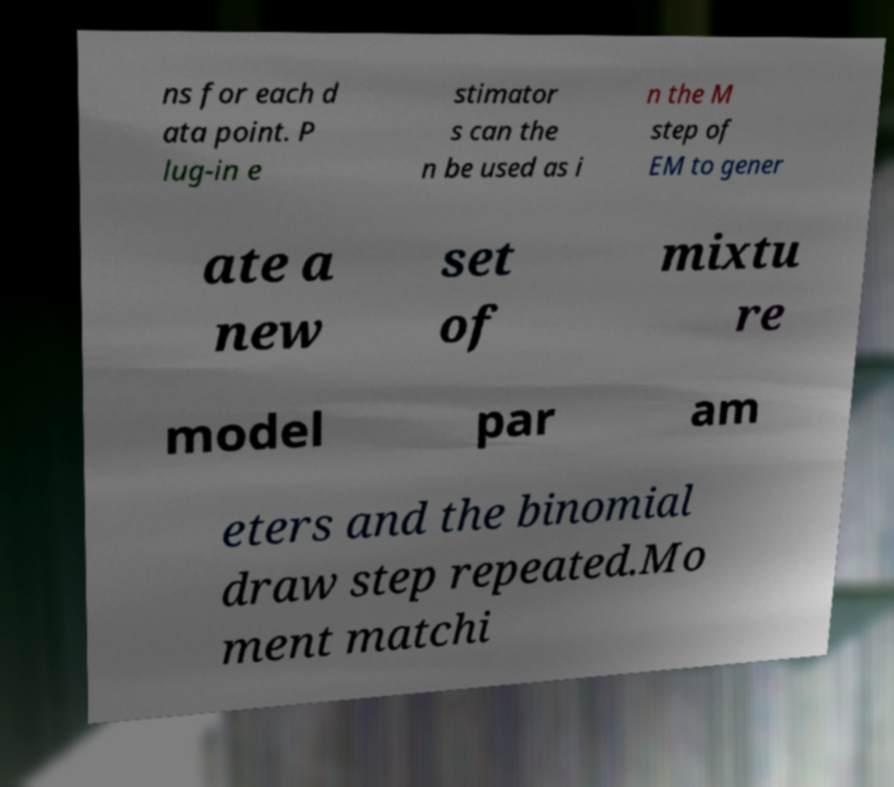Can you read and provide the text displayed in the image?This photo seems to have some interesting text. Can you extract and type it out for me? ns for each d ata point. P lug-in e stimator s can the n be used as i n the M step of EM to gener ate a new set of mixtu re model par am eters and the binomial draw step repeated.Mo ment matchi 